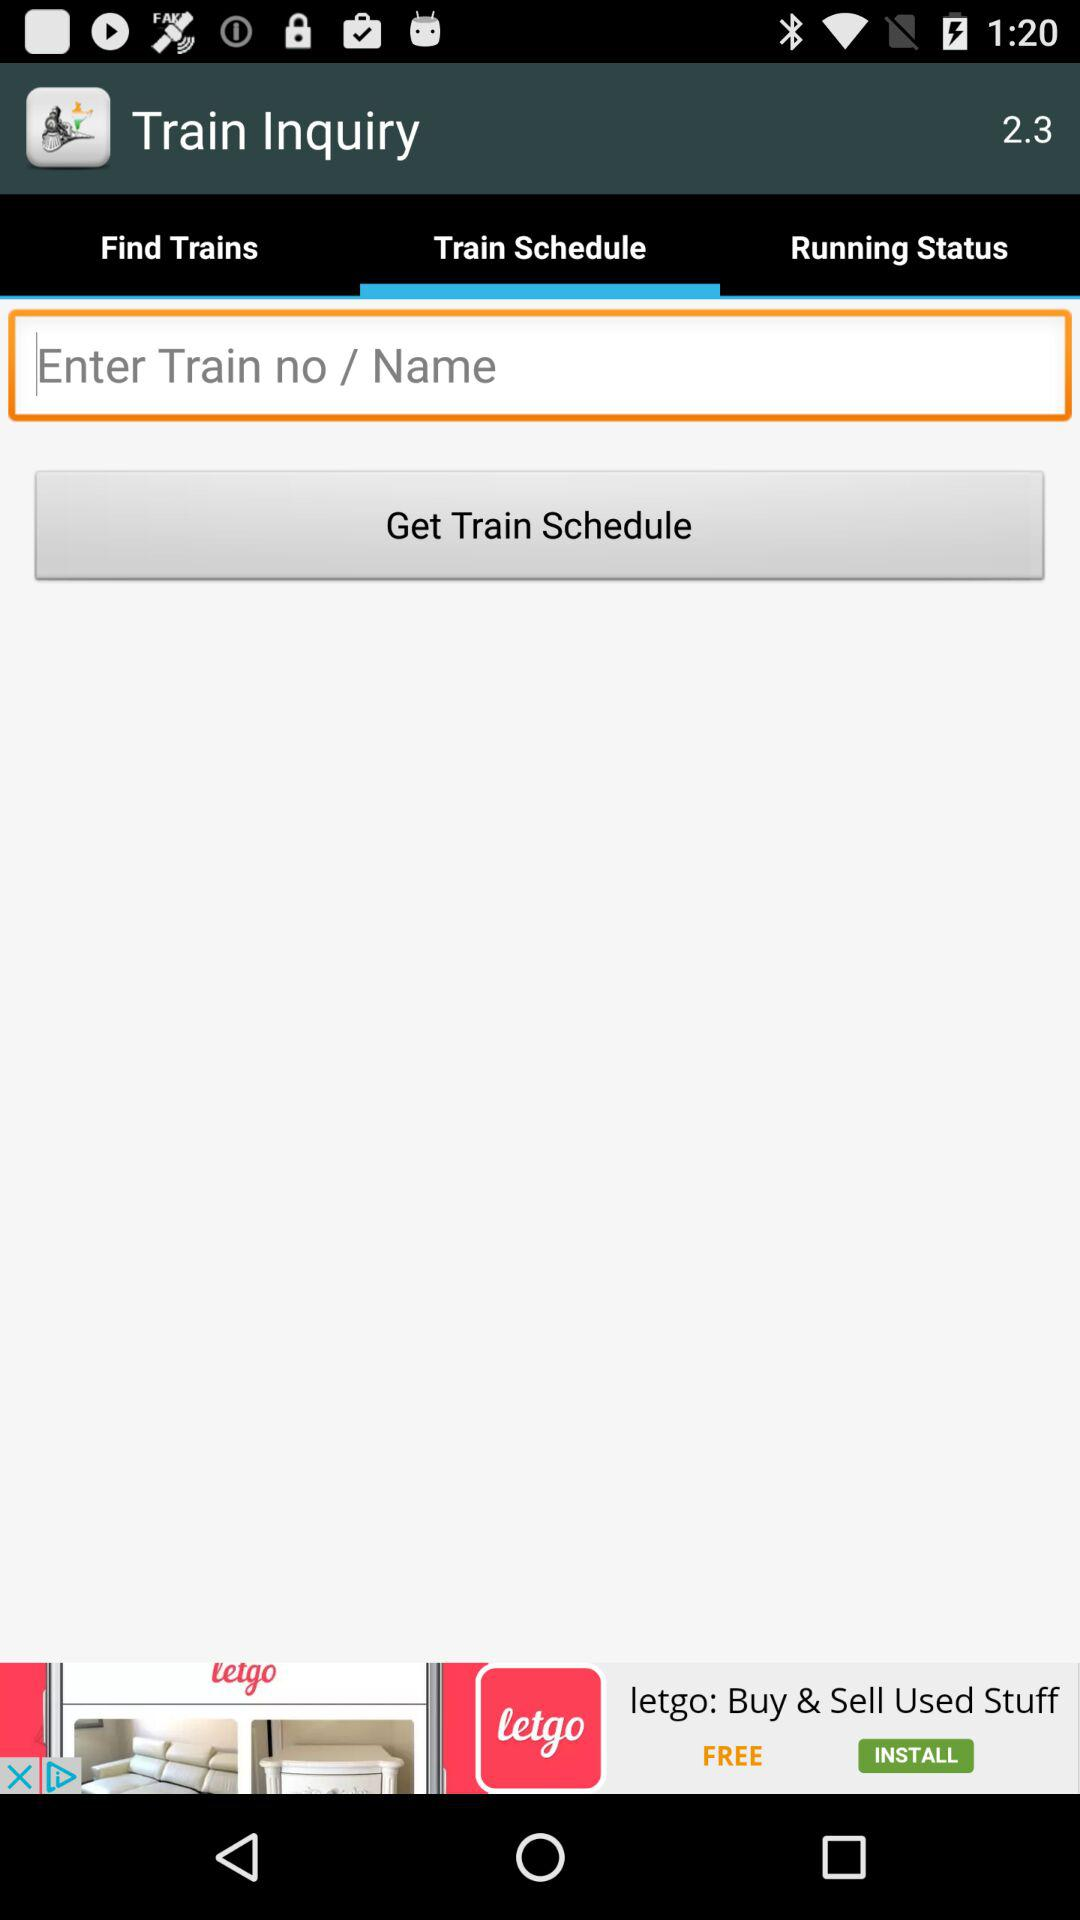Which tab is selected? The selected tab is "Train Schedule". 